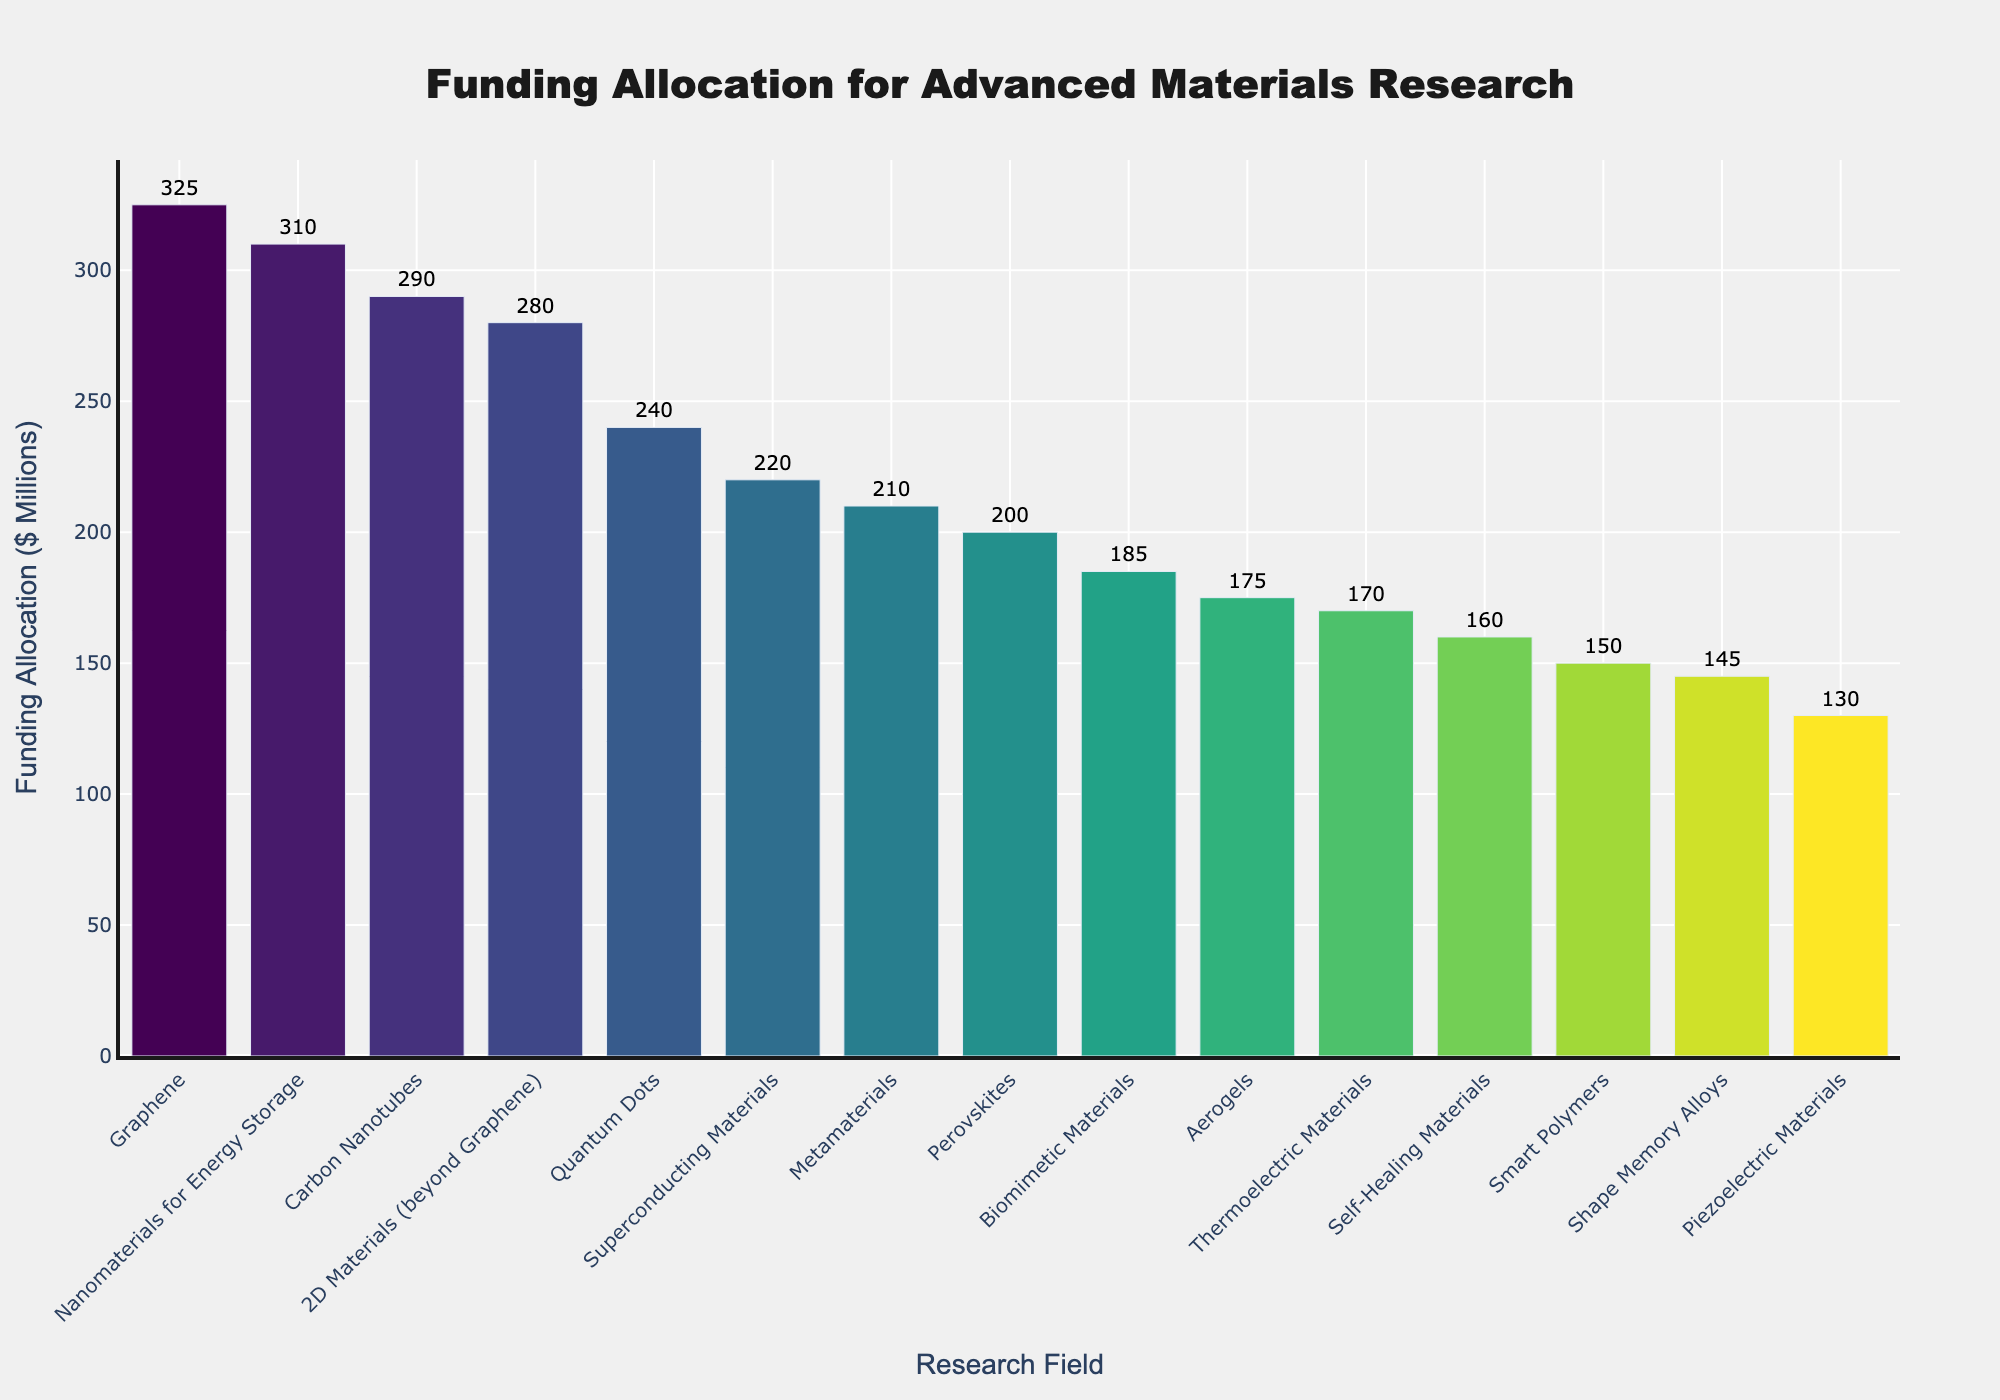Which research field received the highest funding allocation? The highest bar represents the field with the most funding. It is Graphene with $325 million.
Answer: Graphene Which research field received less funding, Smart Polymers or Shape Memory Alloys? Compare the bars for Smart Polymers and Shape Memory Alloys. Smart Polymers received $150M while Shape Memory Alloys received $145M.
Answer: Shape Memory Alloys What is the sum of the funding allocations for Nanomaterials for Energy Storage and Carbon Nanotubes? Add the funding for Nanomaterials for Energy Storage ($310M) and Carbon Nanotubes ($290M). The total is $600M.
Answer: $600M Which research field received the least funding? The shortest bar indicates the field with the least funding, which is Piezoelectric Materials with $130 million.
Answer: Piezoelectric Materials How much more funding did Graphene receive compared to Perovskites? Subtract the funding for Perovskites ($200M) from Graphene ($325M). The difference is $125M.
Answer: $125M How many research fields received funding between $200 million and $300 million? Count the bars within the specified range ($200M to $300M): Metamaterials, Quantum Dots, Perovskites, Superconducting Materials, and 2D Materials (beyond Graphene).
Answer: 5 Which research field received funding closest to the median funding allocation? List the funding allocations, find the median, and identify the closest. The median of 15 values is the 8th value: $185M for Biomimetic Materials.
Answer: Biomimetic Materials What is the average funding allocation for all research fields? Sum all funding amounts and divide by the number of fields. The total is $3,590M, so the average is $3,590M / 15 ≈ $239.33M.
Answer: $239.33M Between Aerogels and Superconducting Materials, which received greater funding, and by how much? Compare their respective funding, Aerogels received $175M and Superconducting Materials received $220M. The difference is $45M.
Answer: Superconducting Materials by $45M What is the funding allocation difference between the field with the highest funding and the field with the lowest funding? Subtract the lowest funding ($130M for Piezoelectric Materials) from the highest ($325M for Graphene). The difference is $195M.
Answer: $195M 